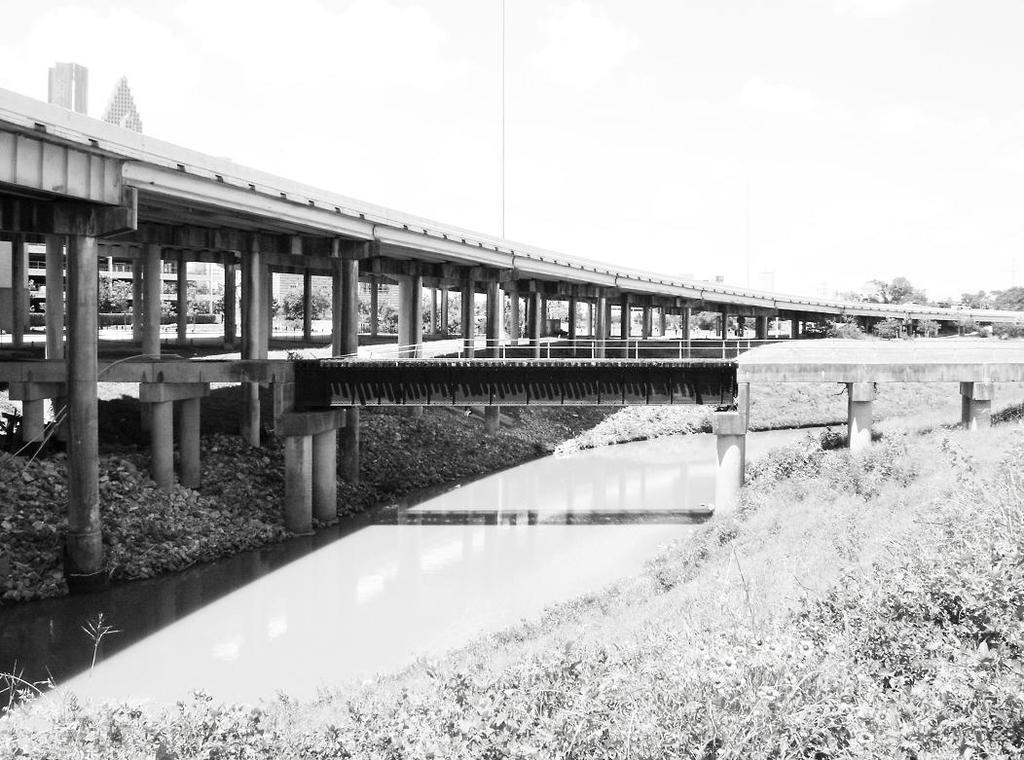Could you give a brief overview of what you see in this image? This image consists of a bridge. At the bottom, there is water. On the right, we can see small plants. At the top, there is sky. In the background, we can see a building and trees. 